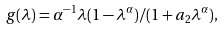<formula> <loc_0><loc_0><loc_500><loc_500>g ( \lambda ) = \alpha ^ { - 1 } \lambda ( 1 - \lambda ^ { \alpha } ) / ( 1 + a _ { 2 } \lambda ^ { \alpha } ) ,</formula> 